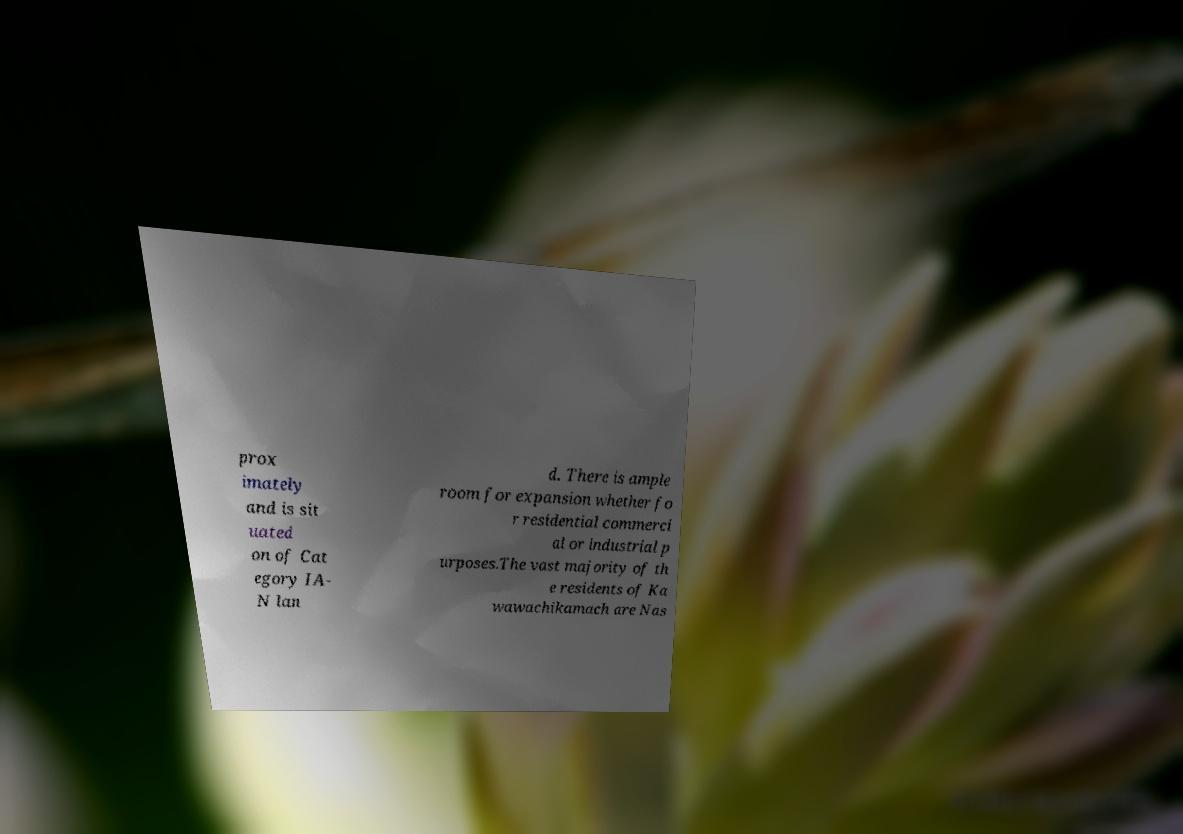There's text embedded in this image that I need extracted. Can you transcribe it verbatim? prox imately and is sit uated on of Cat egory IA- N lan d. There is ample room for expansion whether fo r residential commerci al or industrial p urposes.The vast majority of th e residents of Ka wawachikamach are Nas 